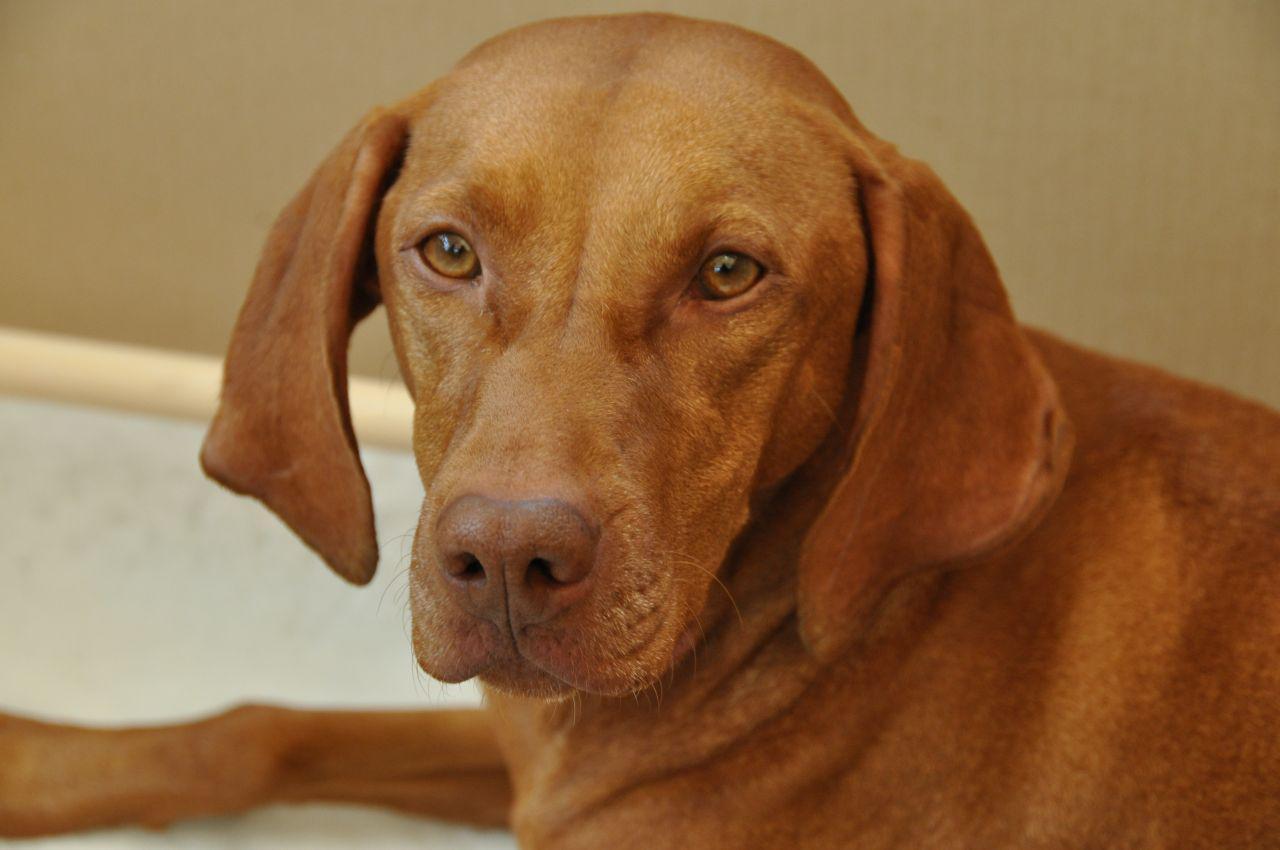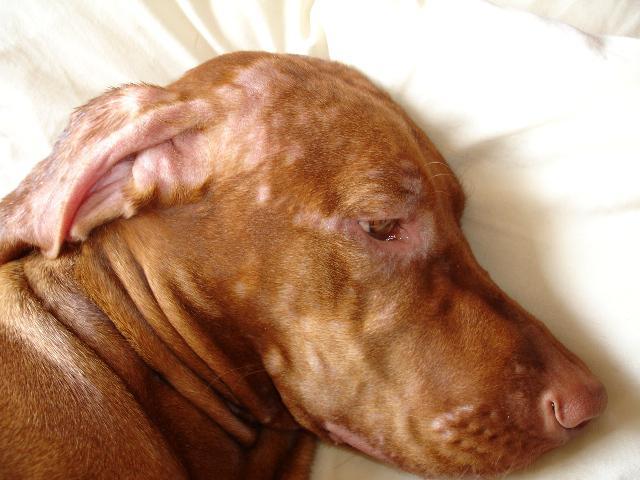The first image is the image on the left, the second image is the image on the right. Examine the images to the left and right. Is the description "The left image contains one reddish-orange dog wearing a red braided cord around its neck." accurate? Answer yes or no. No. The first image is the image on the left, the second image is the image on the right. Analyze the images presented: Is the assertion "At least one hound has a red collar around its neck." valid? Answer yes or no. No. 